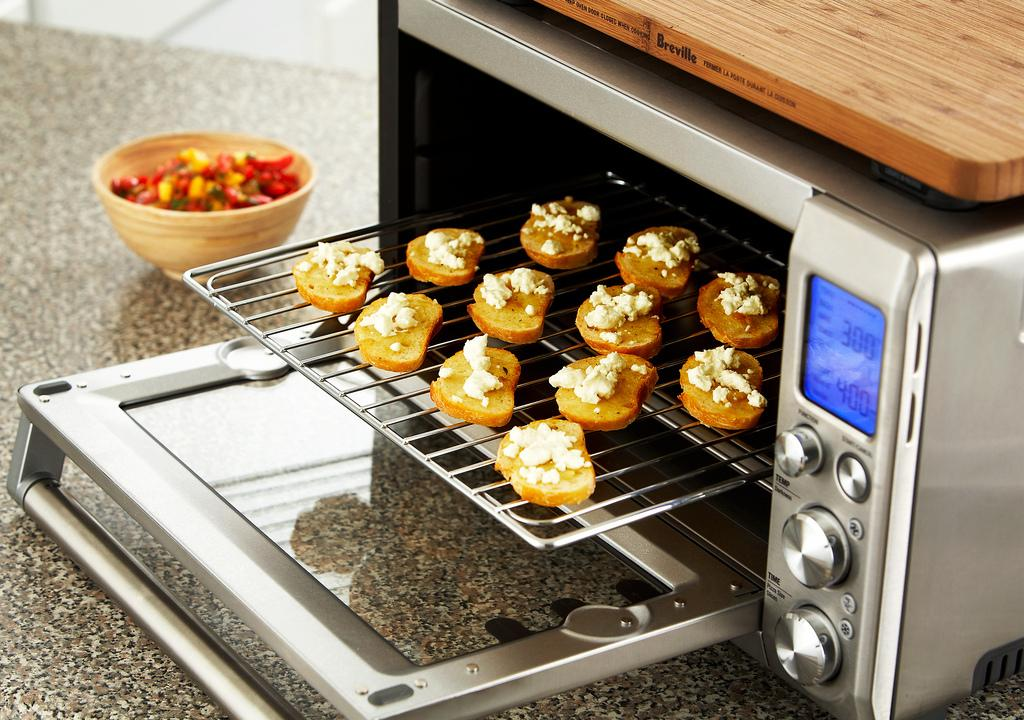<image>
Present a compact description of the photo's key features. A toaster oven is set to 400 degrees with cookies in it. 